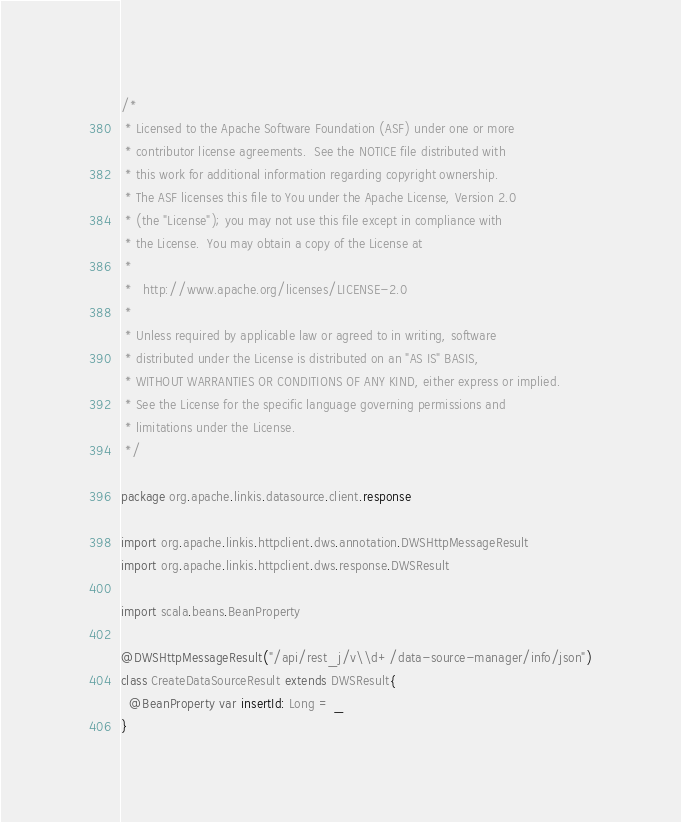<code> <loc_0><loc_0><loc_500><loc_500><_Scala_>/*
 * Licensed to the Apache Software Foundation (ASF) under one or more
 * contributor license agreements.  See the NOTICE file distributed with
 * this work for additional information regarding copyright ownership.
 * The ASF licenses this file to You under the Apache License, Version 2.0
 * (the "License"); you may not use this file except in compliance with
 * the License.  You may obtain a copy of the License at
 *
 *   http://www.apache.org/licenses/LICENSE-2.0
 *
 * Unless required by applicable law or agreed to in writing, software
 * distributed under the License is distributed on an "AS IS" BASIS,
 * WITHOUT WARRANTIES OR CONDITIONS OF ANY KIND, either express or implied.
 * See the License for the specific language governing permissions and
 * limitations under the License.
 */

package org.apache.linkis.datasource.client.response

import org.apache.linkis.httpclient.dws.annotation.DWSHttpMessageResult
import org.apache.linkis.httpclient.dws.response.DWSResult

import scala.beans.BeanProperty

@DWSHttpMessageResult("/api/rest_j/v\\d+/data-source-manager/info/json")
class CreateDataSourceResult extends DWSResult{
  @BeanProperty var insertId: Long = _
}
</code> 